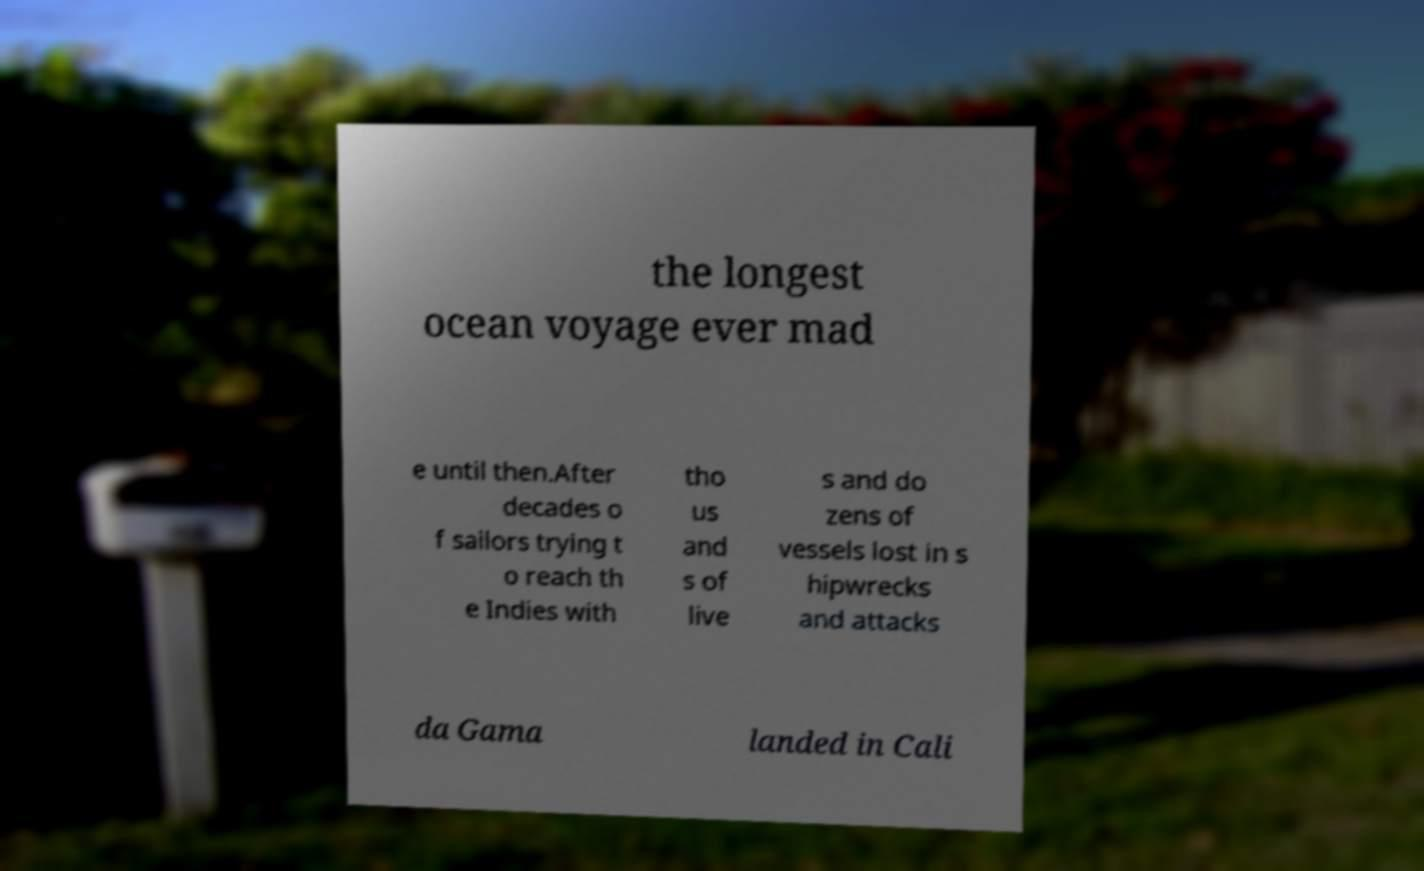For documentation purposes, I need the text within this image transcribed. Could you provide that? the longest ocean voyage ever mad e until then.After decades o f sailors trying t o reach th e Indies with tho us and s of live s and do zens of vessels lost in s hipwrecks and attacks da Gama landed in Cali 